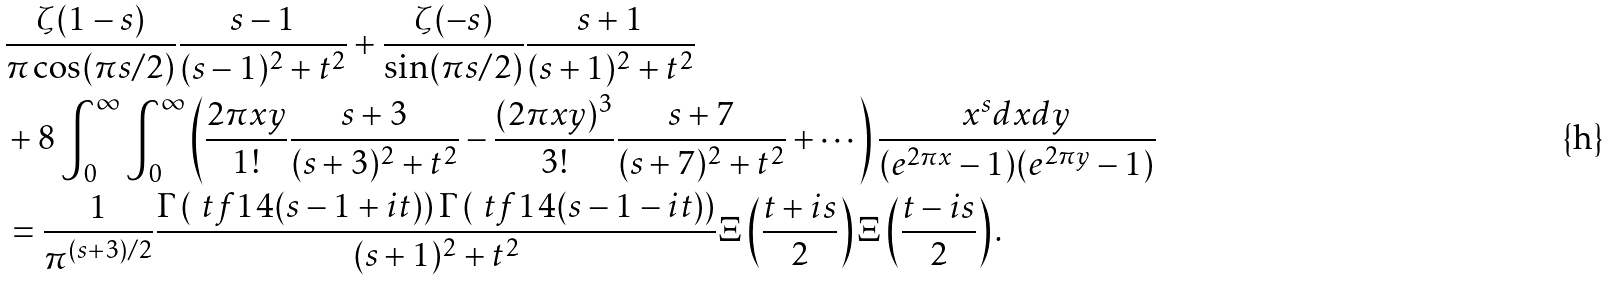Convert formula to latex. <formula><loc_0><loc_0><loc_500><loc_500>& \frac { \zeta ( 1 - s ) } { \pi \cos ( \pi s / 2 ) } \frac { s - 1 } { ( s - 1 ) ^ { 2 } + t ^ { 2 } } + \frac { \zeta ( - s ) } { \sin ( \pi s / 2 ) } \frac { s + 1 } { ( s + 1 ) ^ { 2 } + t ^ { 2 } } \\ & + 8 \int _ { 0 } ^ { \infty } \int _ { 0 } ^ { \infty } \left ( \frac { 2 \pi x y } { 1 ! } \frac { s + 3 } { ( s + 3 ) ^ { 2 } + t ^ { 2 } } - \frac { ( 2 \pi x y ) ^ { 3 } } { 3 ! } \frac { s + 7 } { ( s + 7 ) ^ { 2 } + t ^ { 2 } } + \cdots \right ) \frac { x ^ { s } d x d y } { ( e ^ { 2 \pi x } - 1 ) ( e ^ { 2 \pi y } - 1 ) } \\ & = \frac { 1 } { \pi ^ { ( s + 3 ) / 2 } } \frac { \Gamma \left ( \ t f { 1 } { 4 } ( s - 1 + i t ) \right ) \Gamma \left ( \ t f { 1 } { 4 } ( s - 1 - i t ) \right ) } { ( s + 1 ) ^ { 2 } + t ^ { 2 } } \Xi \left ( \frac { t + i s } { 2 } \right ) \Xi \left ( \frac { t - i s } { 2 } \right ) .</formula> 